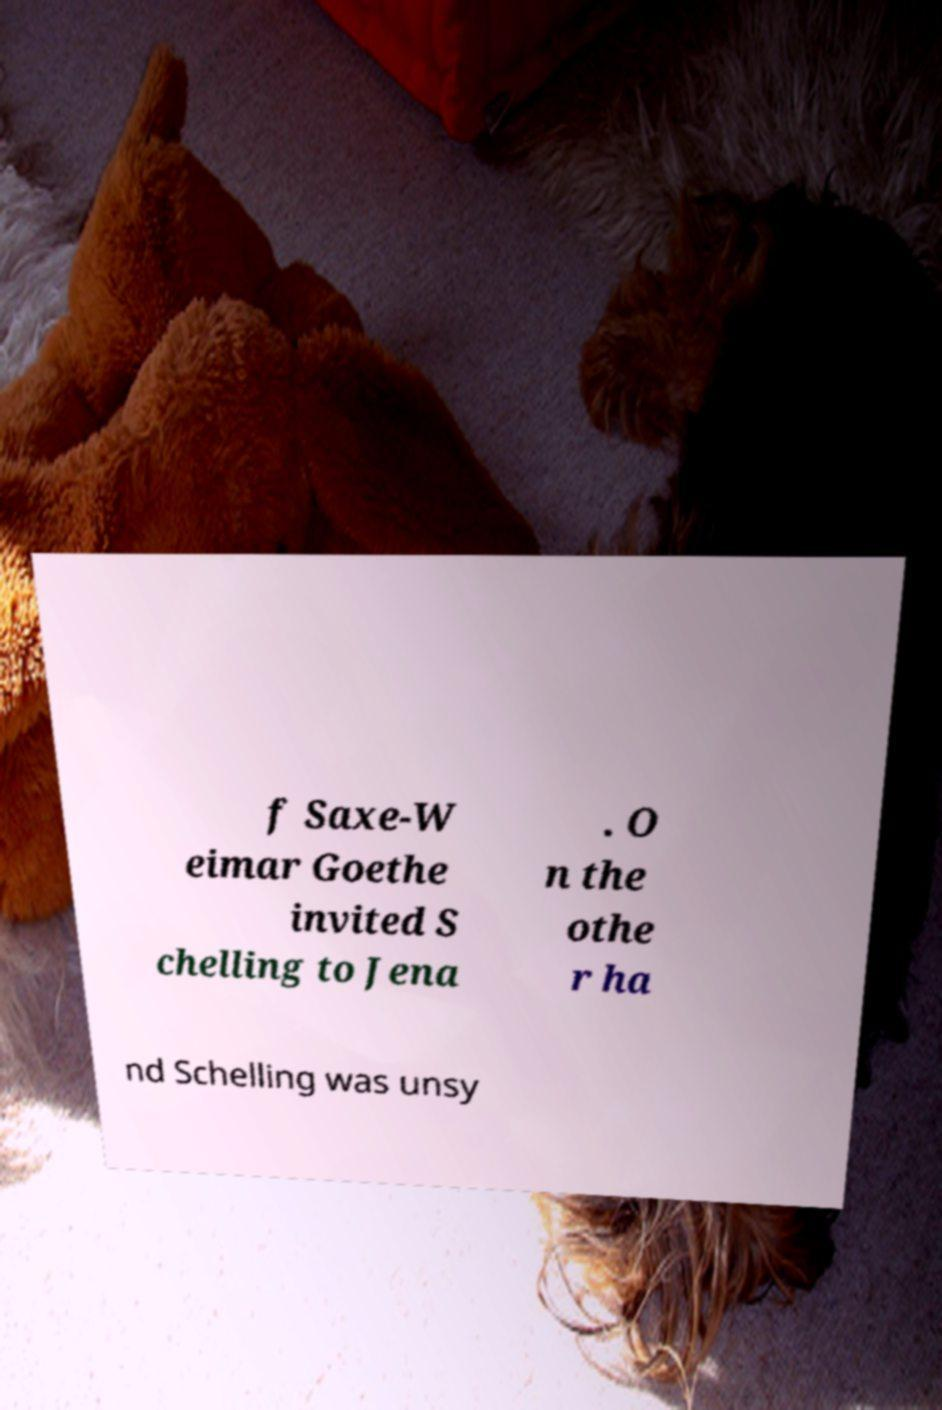I need the written content from this picture converted into text. Can you do that? f Saxe-W eimar Goethe invited S chelling to Jena . O n the othe r ha nd Schelling was unsy 